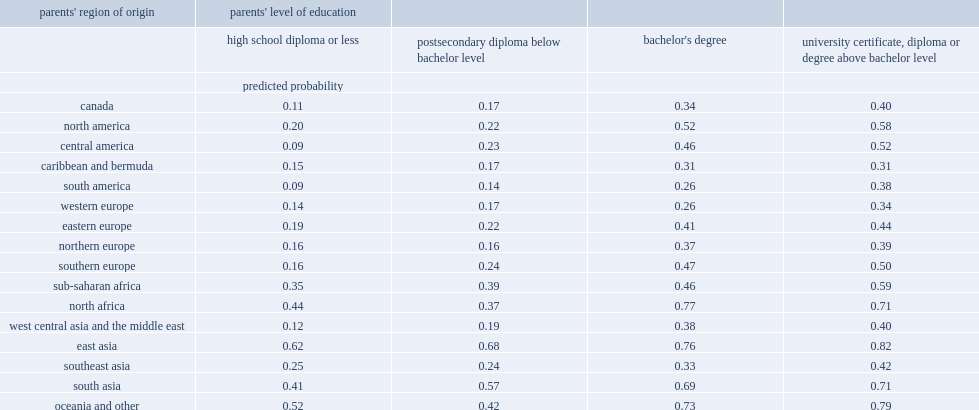Specifically, among canadian youth from the third generation or more whose parents had a high school diploma or less, what was the predicted probability (adjusted for other factors) of having a university degree? 0.11. For youth with an immigrant background from east asia whose parents had a high school diploma or less, what was their probability of having a university degree? 0.62. What was the probability of canadian youth from the third generation or more whose parents had a university degree above the bachelor level? 0.4. 